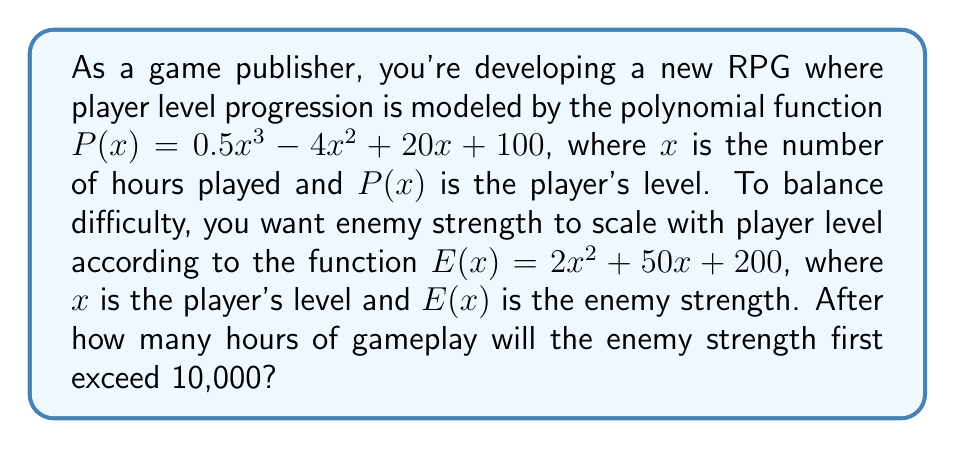Help me with this question. To solve this problem, we need to follow these steps:

1) First, we need to find the player's level at which the enemy strength exceeds 10,000. We can do this by solving the equation:

   $E(x) = 10000$
   $2x^2 + 50x + 200 = 10000$
   $2x^2 + 50x - 9800 = 0$

2) This is a quadratic equation. We can solve it using the quadratic formula:
   $x = \frac{-b \pm \sqrt{b^2 - 4ac}}{2a}$

   Where $a = 2$, $b = 50$, and $c = -9800$

3) Plugging these values into the quadratic formula:

   $x = \frac{-50 \pm \sqrt{50^2 - 4(2)(-9800)}}{2(2)}$
   $x = \frac{-50 \pm \sqrt{2500 + 78400}}{4}$
   $x = \frac{-50 \pm \sqrt{80900}}{4}$
   $x = \frac{-50 \pm 284.43}{4}$

4) This gives us two solutions:
   $x_1 = \frac{-50 + 284.43}{4} = 58.61$
   $x_2 = \frac{-50 - 284.43}{4} = -83.61$

   Since levels can't be negative, we take the positive solution. The enemy strength will exceed 10,000 when the player's level reaches 58.61.

5) Now we need to find how many hours of gameplay it takes to reach this level. We do this by solving:

   $P(x) = 58.61$
   $0.5x^3 - 4x^2 + 20x + 100 = 58.61$

6) This is a cubic equation. It's complex to solve algebraically, so we'll use numerical methods. Using a graphing calculator or computer algebra system, we find that this equation is satisfied when $x \approx 13.76$.

Therefore, the enemy strength will first exceed 10,000 after approximately 13.76 hours of gameplay.
Answer: Approximately 13.76 hours 